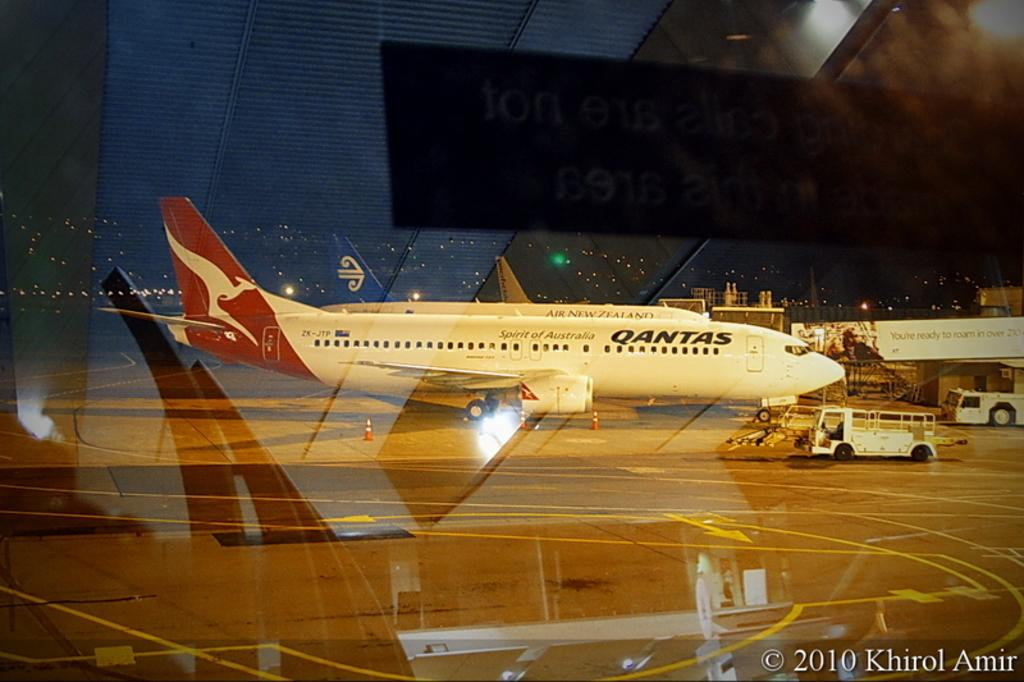<image>
Render a clear and concise summary of the photo. a red and white Qantas Airplane sitting on a runway. 